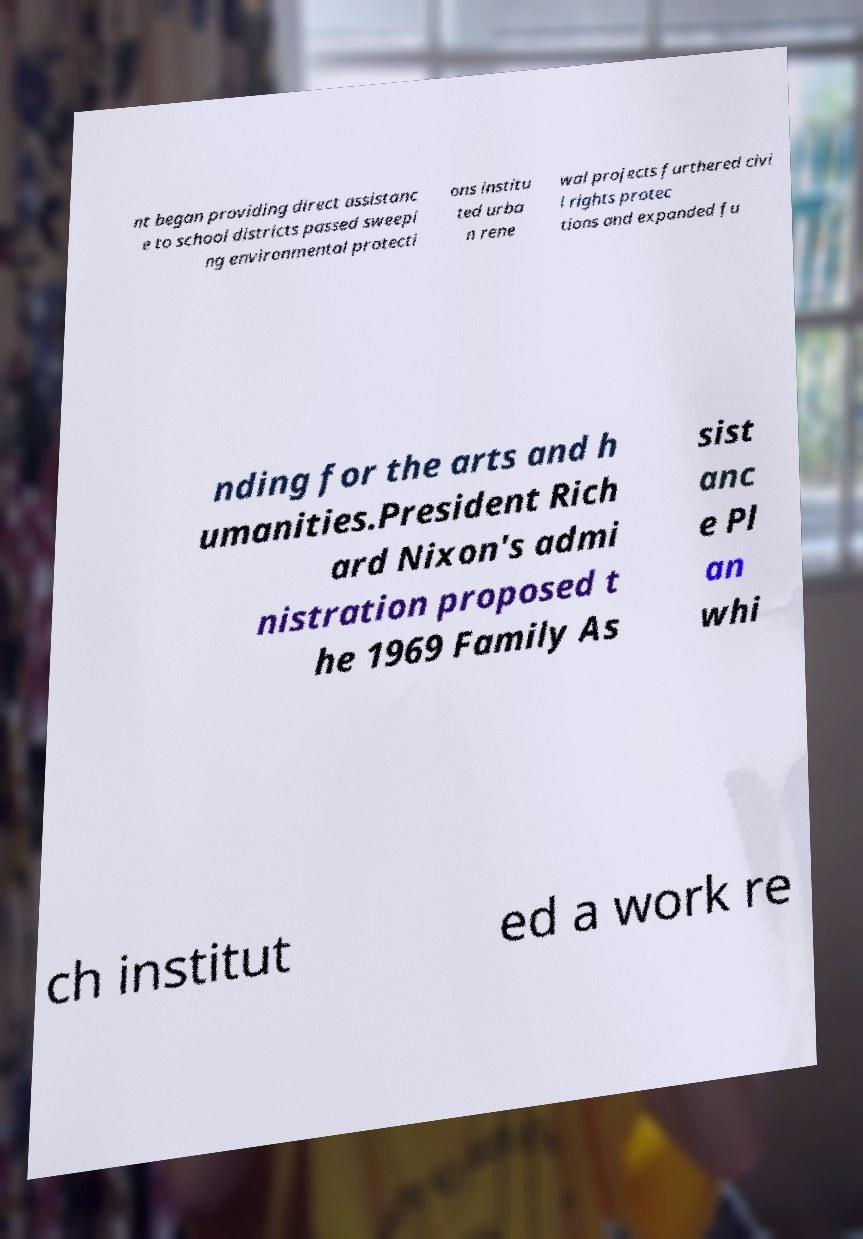Can you accurately transcribe the text from the provided image for me? nt began providing direct assistanc e to school districts passed sweepi ng environmental protecti ons institu ted urba n rene wal projects furthered civi l rights protec tions and expanded fu nding for the arts and h umanities.President Rich ard Nixon's admi nistration proposed t he 1969 Family As sist anc e Pl an whi ch institut ed a work re 